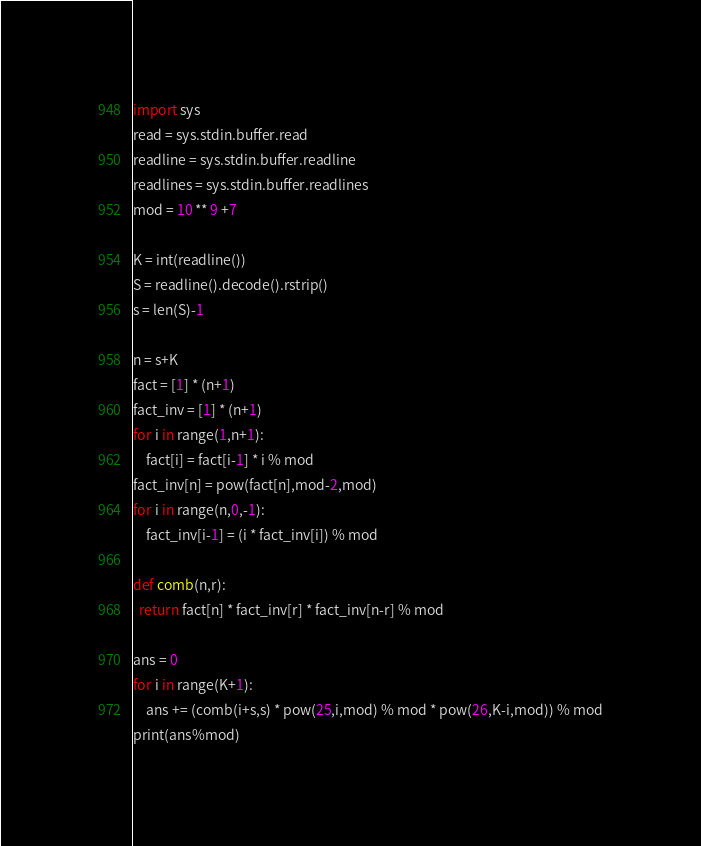Convert code to text. <code><loc_0><loc_0><loc_500><loc_500><_Python_>import sys 
read = sys.stdin.buffer.read
readline = sys.stdin.buffer.readline
readlines = sys.stdin.buffer.readlines
mod = 10 ** 9 +7
    
K = int(readline())
S = readline().decode().rstrip()
s = len(S)-1

n = s+K
fact = [1] * (n+1)
fact_inv = [1] * (n+1)
for i in range(1,n+1):
    fact[i] = fact[i-1] * i % mod 
fact_inv[n] = pow(fact[n],mod-2,mod)
for i in range(n,0,-1):
    fact_inv[i-1] = (i * fact_inv[i]) % mod 

def comb(n,r):
  return fact[n] * fact_inv[r] * fact_inv[n-r] % mod

ans = 0
for i in range(K+1):
    ans += (comb(i+s,s) * pow(25,i,mod) % mod * pow(26,K-i,mod)) % mod
print(ans%mod)</code> 